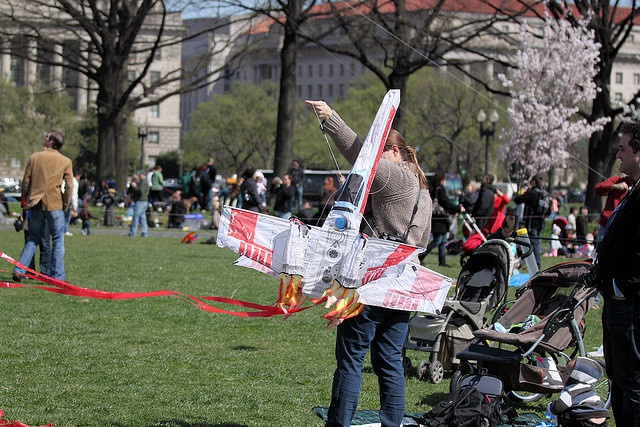Describe the objects in this image and their specific colors. I can see kite in darkgray, lavender, gray, and salmon tones, people in darkgray, black, gray, and lavender tones, people in darkgray, black, gray, and darkblue tones, people in darkgray, black, gray, and navy tones, and people in darkgray, black, gray, and tan tones in this image. 